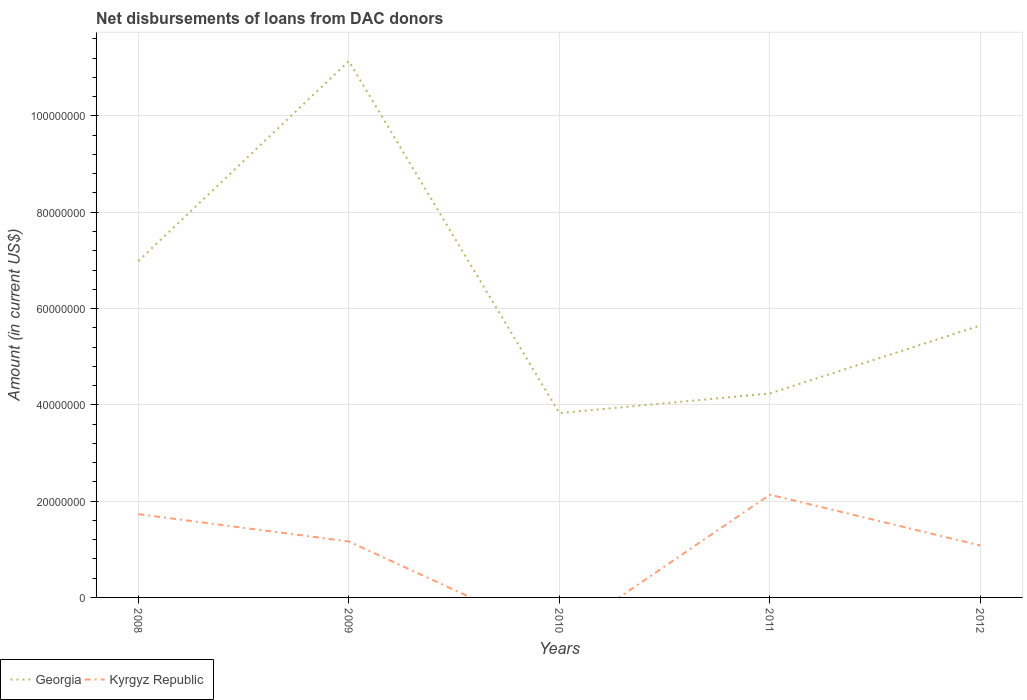How many different coloured lines are there?
Offer a terse response. 2. Is the number of lines equal to the number of legend labels?
Your response must be concise. No. What is the total amount of loans disbursed in Georgia in the graph?
Offer a very short reply. 5.49e+07. What is the difference between the highest and the second highest amount of loans disbursed in Georgia?
Offer a terse response. 7.31e+07. Is the amount of loans disbursed in Georgia strictly greater than the amount of loans disbursed in Kyrgyz Republic over the years?
Offer a terse response. No. Are the values on the major ticks of Y-axis written in scientific E-notation?
Provide a succinct answer. No. How are the legend labels stacked?
Your response must be concise. Horizontal. What is the title of the graph?
Provide a short and direct response. Net disbursements of loans from DAC donors. Does "Aruba" appear as one of the legend labels in the graph?
Give a very brief answer. No. What is the label or title of the Y-axis?
Your answer should be compact. Amount (in current US$). What is the Amount (in current US$) of Georgia in 2008?
Your response must be concise. 6.99e+07. What is the Amount (in current US$) in Kyrgyz Republic in 2008?
Offer a terse response. 1.73e+07. What is the Amount (in current US$) in Georgia in 2009?
Keep it short and to the point. 1.11e+08. What is the Amount (in current US$) in Kyrgyz Republic in 2009?
Provide a succinct answer. 1.16e+07. What is the Amount (in current US$) in Georgia in 2010?
Provide a succinct answer. 3.83e+07. What is the Amount (in current US$) of Kyrgyz Republic in 2010?
Ensure brevity in your answer.  0. What is the Amount (in current US$) of Georgia in 2011?
Ensure brevity in your answer.  4.24e+07. What is the Amount (in current US$) of Kyrgyz Republic in 2011?
Offer a terse response. 2.13e+07. What is the Amount (in current US$) in Georgia in 2012?
Keep it short and to the point. 5.65e+07. What is the Amount (in current US$) in Kyrgyz Republic in 2012?
Offer a terse response. 1.08e+07. Across all years, what is the maximum Amount (in current US$) in Georgia?
Your answer should be compact. 1.11e+08. Across all years, what is the maximum Amount (in current US$) in Kyrgyz Republic?
Your response must be concise. 2.13e+07. Across all years, what is the minimum Amount (in current US$) of Georgia?
Offer a very short reply. 3.83e+07. Across all years, what is the minimum Amount (in current US$) of Kyrgyz Republic?
Provide a short and direct response. 0. What is the total Amount (in current US$) in Georgia in the graph?
Keep it short and to the point. 3.18e+08. What is the total Amount (in current US$) in Kyrgyz Republic in the graph?
Offer a terse response. 6.10e+07. What is the difference between the Amount (in current US$) in Georgia in 2008 and that in 2009?
Offer a very short reply. -4.15e+07. What is the difference between the Amount (in current US$) in Kyrgyz Republic in 2008 and that in 2009?
Offer a very short reply. 5.67e+06. What is the difference between the Amount (in current US$) of Georgia in 2008 and that in 2010?
Your response must be concise. 3.16e+07. What is the difference between the Amount (in current US$) of Georgia in 2008 and that in 2011?
Your response must be concise. 2.75e+07. What is the difference between the Amount (in current US$) of Kyrgyz Republic in 2008 and that in 2011?
Your response must be concise. -4.04e+06. What is the difference between the Amount (in current US$) of Georgia in 2008 and that in 2012?
Your answer should be compact. 1.34e+07. What is the difference between the Amount (in current US$) in Kyrgyz Republic in 2008 and that in 2012?
Keep it short and to the point. 6.51e+06. What is the difference between the Amount (in current US$) in Georgia in 2009 and that in 2010?
Make the answer very short. 7.31e+07. What is the difference between the Amount (in current US$) of Georgia in 2009 and that in 2011?
Offer a very short reply. 6.90e+07. What is the difference between the Amount (in current US$) of Kyrgyz Republic in 2009 and that in 2011?
Give a very brief answer. -9.72e+06. What is the difference between the Amount (in current US$) of Georgia in 2009 and that in 2012?
Give a very brief answer. 5.49e+07. What is the difference between the Amount (in current US$) in Kyrgyz Republic in 2009 and that in 2012?
Provide a short and direct response. 8.36e+05. What is the difference between the Amount (in current US$) of Georgia in 2010 and that in 2011?
Your answer should be very brief. -4.08e+06. What is the difference between the Amount (in current US$) of Georgia in 2010 and that in 2012?
Keep it short and to the point. -1.82e+07. What is the difference between the Amount (in current US$) of Georgia in 2011 and that in 2012?
Keep it short and to the point. -1.41e+07. What is the difference between the Amount (in current US$) in Kyrgyz Republic in 2011 and that in 2012?
Provide a succinct answer. 1.06e+07. What is the difference between the Amount (in current US$) of Georgia in 2008 and the Amount (in current US$) of Kyrgyz Republic in 2009?
Make the answer very short. 5.82e+07. What is the difference between the Amount (in current US$) of Georgia in 2008 and the Amount (in current US$) of Kyrgyz Republic in 2011?
Keep it short and to the point. 4.85e+07. What is the difference between the Amount (in current US$) of Georgia in 2008 and the Amount (in current US$) of Kyrgyz Republic in 2012?
Make the answer very short. 5.91e+07. What is the difference between the Amount (in current US$) in Georgia in 2009 and the Amount (in current US$) in Kyrgyz Republic in 2011?
Offer a terse response. 9.00e+07. What is the difference between the Amount (in current US$) in Georgia in 2009 and the Amount (in current US$) in Kyrgyz Republic in 2012?
Give a very brief answer. 1.01e+08. What is the difference between the Amount (in current US$) of Georgia in 2010 and the Amount (in current US$) of Kyrgyz Republic in 2011?
Provide a short and direct response. 1.69e+07. What is the difference between the Amount (in current US$) of Georgia in 2010 and the Amount (in current US$) of Kyrgyz Republic in 2012?
Provide a short and direct response. 2.75e+07. What is the difference between the Amount (in current US$) of Georgia in 2011 and the Amount (in current US$) of Kyrgyz Republic in 2012?
Ensure brevity in your answer.  3.16e+07. What is the average Amount (in current US$) in Georgia per year?
Your answer should be very brief. 6.37e+07. What is the average Amount (in current US$) of Kyrgyz Republic per year?
Keep it short and to the point. 1.22e+07. In the year 2008, what is the difference between the Amount (in current US$) of Georgia and Amount (in current US$) of Kyrgyz Republic?
Offer a very short reply. 5.26e+07. In the year 2009, what is the difference between the Amount (in current US$) in Georgia and Amount (in current US$) in Kyrgyz Republic?
Your answer should be very brief. 9.98e+07. In the year 2011, what is the difference between the Amount (in current US$) of Georgia and Amount (in current US$) of Kyrgyz Republic?
Your answer should be compact. 2.10e+07. In the year 2012, what is the difference between the Amount (in current US$) of Georgia and Amount (in current US$) of Kyrgyz Republic?
Provide a short and direct response. 4.57e+07. What is the ratio of the Amount (in current US$) of Georgia in 2008 to that in 2009?
Ensure brevity in your answer.  0.63. What is the ratio of the Amount (in current US$) in Kyrgyz Republic in 2008 to that in 2009?
Your answer should be very brief. 1.49. What is the ratio of the Amount (in current US$) of Georgia in 2008 to that in 2010?
Keep it short and to the point. 1.82. What is the ratio of the Amount (in current US$) in Georgia in 2008 to that in 2011?
Your answer should be compact. 1.65. What is the ratio of the Amount (in current US$) of Kyrgyz Republic in 2008 to that in 2011?
Offer a very short reply. 0.81. What is the ratio of the Amount (in current US$) of Georgia in 2008 to that in 2012?
Your response must be concise. 1.24. What is the ratio of the Amount (in current US$) in Kyrgyz Republic in 2008 to that in 2012?
Provide a succinct answer. 1.6. What is the ratio of the Amount (in current US$) in Georgia in 2009 to that in 2010?
Ensure brevity in your answer.  2.91. What is the ratio of the Amount (in current US$) in Georgia in 2009 to that in 2011?
Keep it short and to the point. 2.63. What is the ratio of the Amount (in current US$) in Kyrgyz Republic in 2009 to that in 2011?
Offer a terse response. 0.54. What is the ratio of the Amount (in current US$) in Georgia in 2009 to that in 2012?
Make the answer very short. 1.97. What is the ratio of the Amount (in current US$) in Kyrgyz Republic in 2009 to that in 2012?
Provide a succinct answer. 1.08. What is the ratio of the Amount (in current US$) of Georgia in 2010 to that in 2011?
Your answer should be very brief. 0.9. What is the ratio of the Amount (in current US$) of Georgia in 2010 to that in 2012?
Keep it short and to the point. 0.68. What is the ratio of the Amount (in current US$) of Kyrgyz Republic in 2011 to that in 2012?
Your answer should be compact. 1.98. What is the difference between the highest and the second highest Amount (in current US$) of Georgia?
Provide a succinct answer. 4.15e+07. What is the difference between the highest and the second highest Amount (in current US$) in Kyrgyz Republic?
Your answer should be compact. 4.04e+06. What is the difference between the highest and the lowest Amount (in current US$) in Georgia?
Provide a short and direct response. 7.31e+07. What is the difference between the highest and the lowest Amount (in current US$) of Kyrgyz Republic?
Make the answer very short. 2.13e+07. 